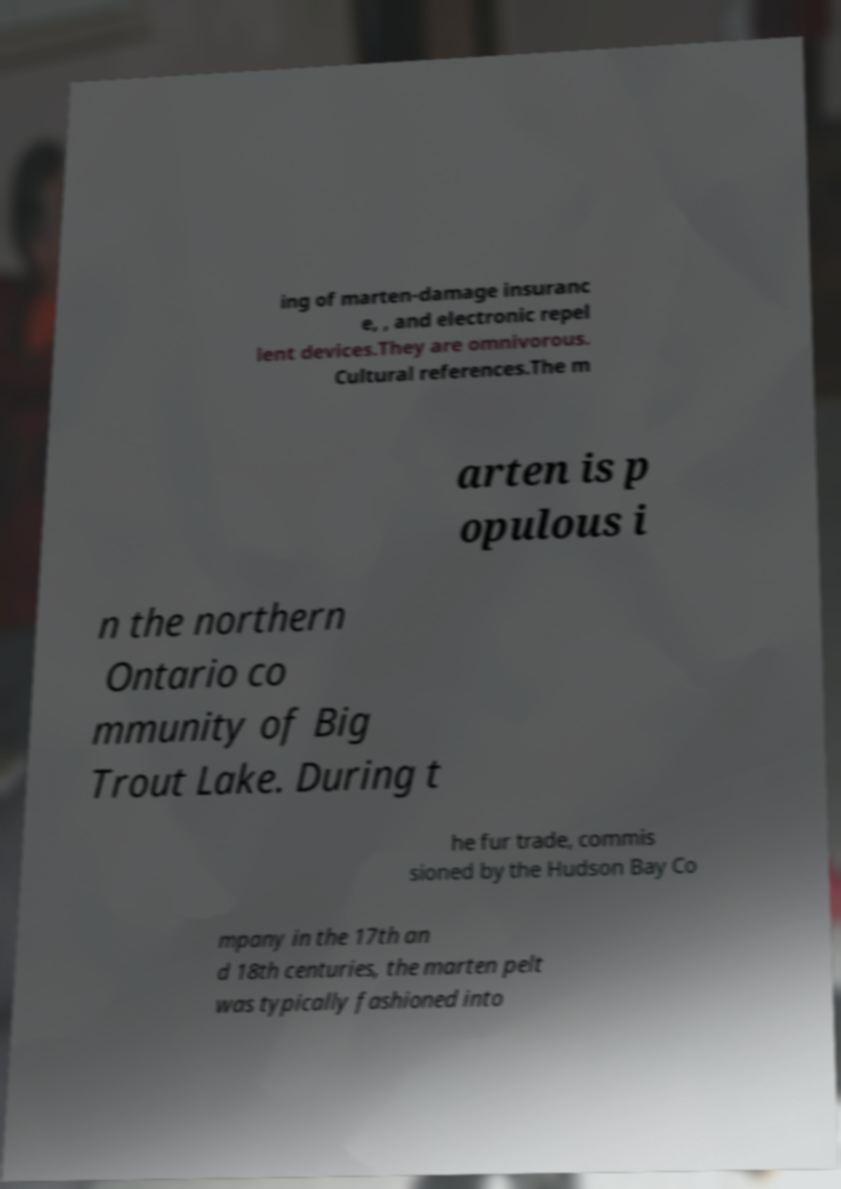Please identify and transcribe the text found in this image. ing of marten-damage insuranc e, , and electronic repel lent devices.They are omnivorous. Cultural references.The m arten is p opulous i n the northern Ontario co mmunity of Big Trout Lake. During t he fur trade, commis sioned by the Hudson Bay Co mpany in the 17th an d 18th centuries, the marten pelt was typically fashioned into 